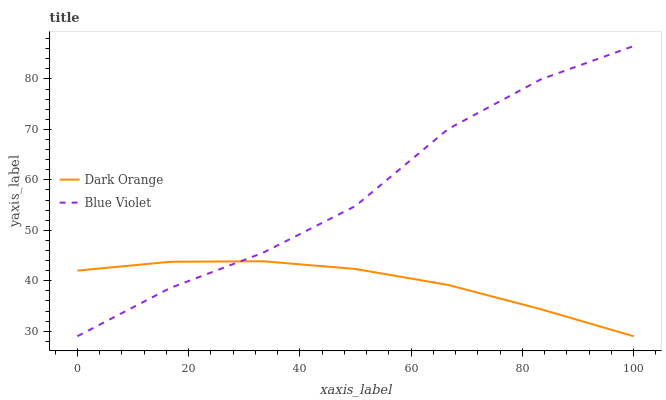Does Dark Orange have the minimum area under the curve?
Answer yes or no. Yes. Does Blue Violet have the maximum area under the curve?
Answer yes or no. Yes. Does Blue Violet have the minimum area under the curve?
Answer yes or no. No. Is Dark Orange the smoothest?
Answer yes or no. Yes. Is Blue Violet the roughest?
Answer yes or no. Yes. Is Blue Violet the smoothest?
Answer yes or no. No. Does Dark Orange have the lowest value?
Answer yes or no. Yes. Does Blue Violet have the highest value?
Answer yes or no. Yes. Does Blue Violet intersect Dark Orange?
Answer yes or no. Yes. Is Blue Violet less than Dark Orange?
Answer yes or no. No. Is Blue Violet greater than Dark Orange?
Answer yes or no. No. 